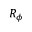Convert formula to latex. <formula><loc_0><loc_0><loc_500><loc_500>R _ { \phi }</formula> 